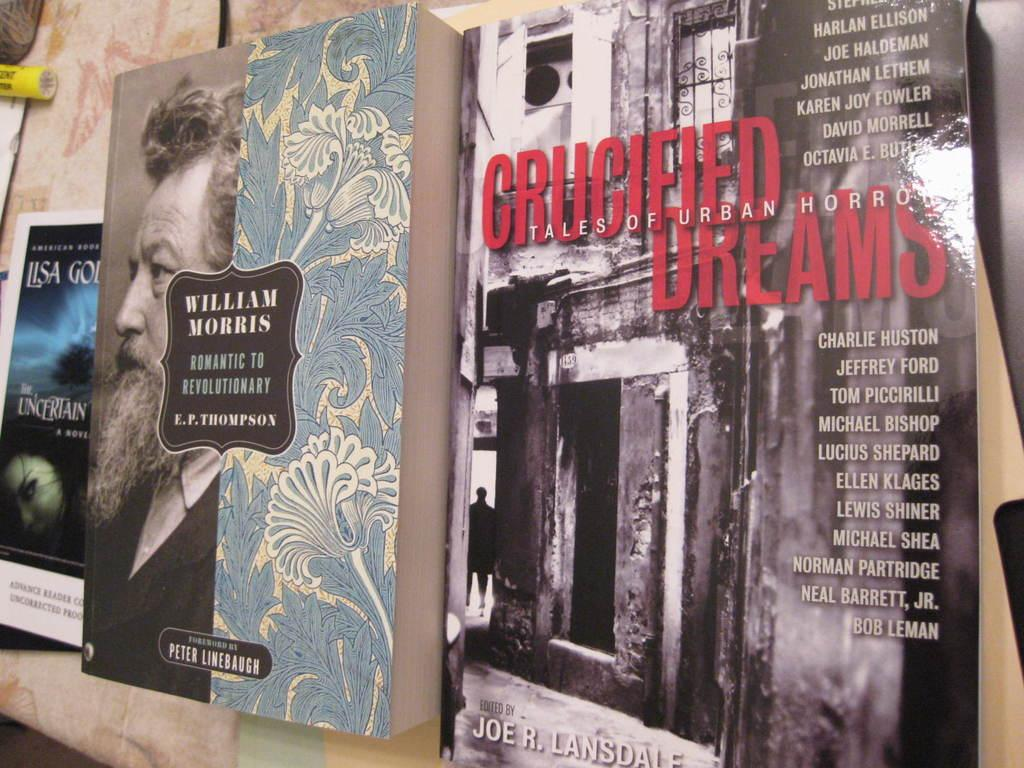Provide a one-sentence caption for the provided image. Books are standing on a ledge including one by William Morris. 